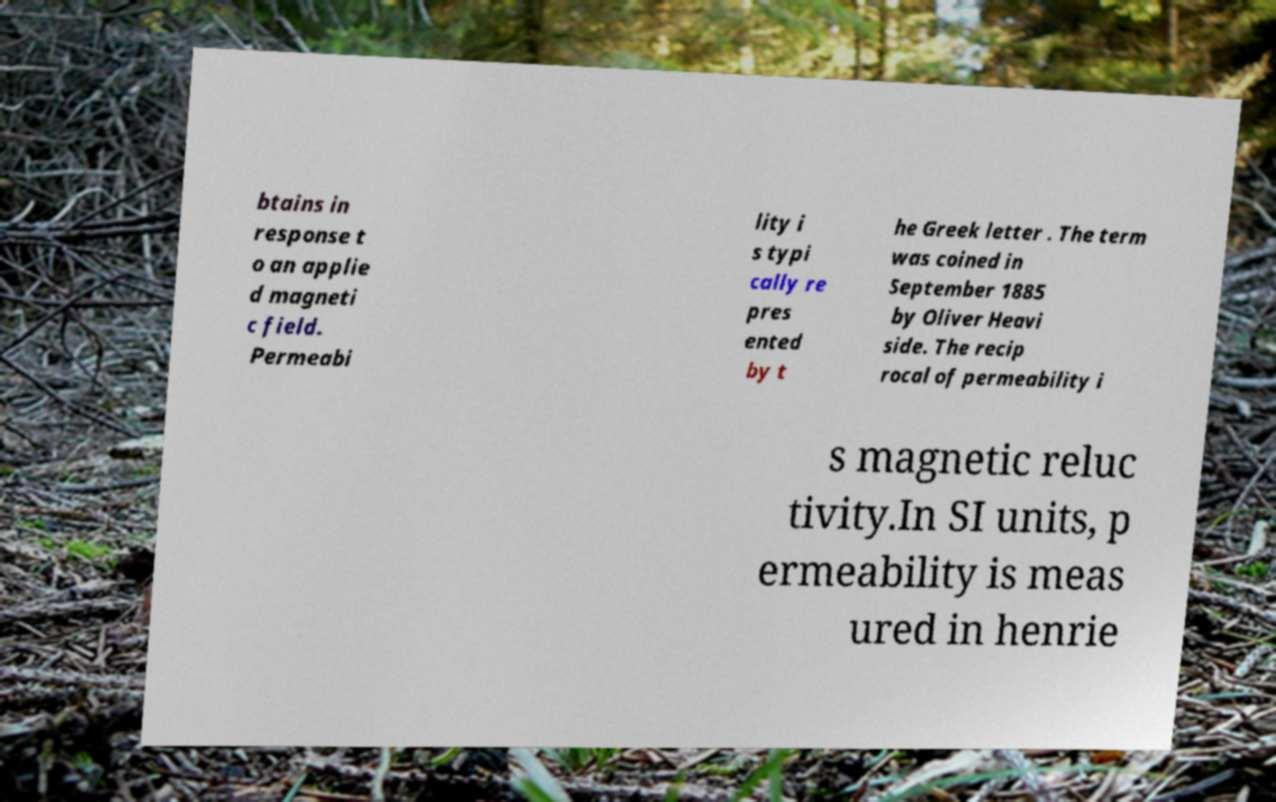I need the written content from this picture converted into text. Can you do that? btains in response t o an applie d magneti c field. Permeabi lity i s typi cally re pres ented by t he Greek letter . The term was coined in September 1885 by Oliver Heavi side. The recip rocal of permeability i s magnetic reluc tivity.In SI units, p ermeability is meas ured in henrie 